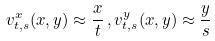Convert formula to latex. <formula><loc_0><loc_0><loc_500><loc_500>v ^ { x } _ { t , s } ( x , y ) \approx \frac { x } { t } \, , v ^ { y } _ { t , s } ( x , y ) \approx \frac { y } { s }</formula> 